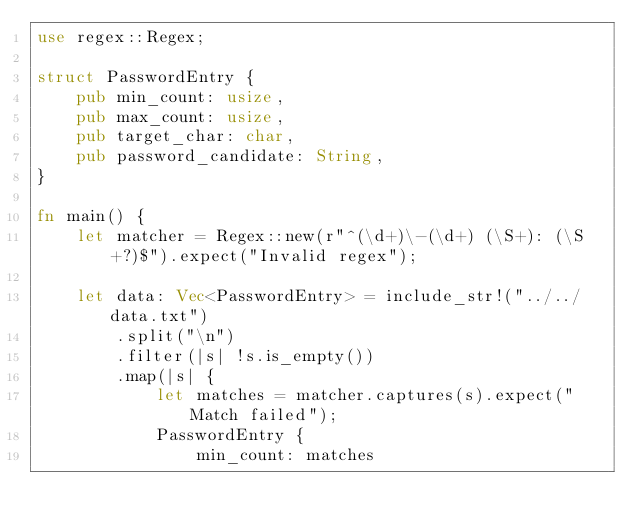<code> <loc_0><loc_0><loc_500><loc_500><_Rust_>use regex::Regex;

struct PasswordEntry {
    pub min_count: usize,
    pub max_count: usize,
    pub target_char: char,
    pub password_candidate: String,
}

fn main() {
    let matcher = Regex::new(r"^(\d+)\-(\d+) (\S+): (\S+?)$").expect("Invalid regex");

    let data: Vec<PasswordEntry> = include_str!("../../data.txt")
        .split("\n")
        .filter(|s| !s.is_empty())
        .map(|s| {
            let matches = matcher.captures(s).expect("Match failed");
            PasswordEntry {
                min_count: matches</code> 